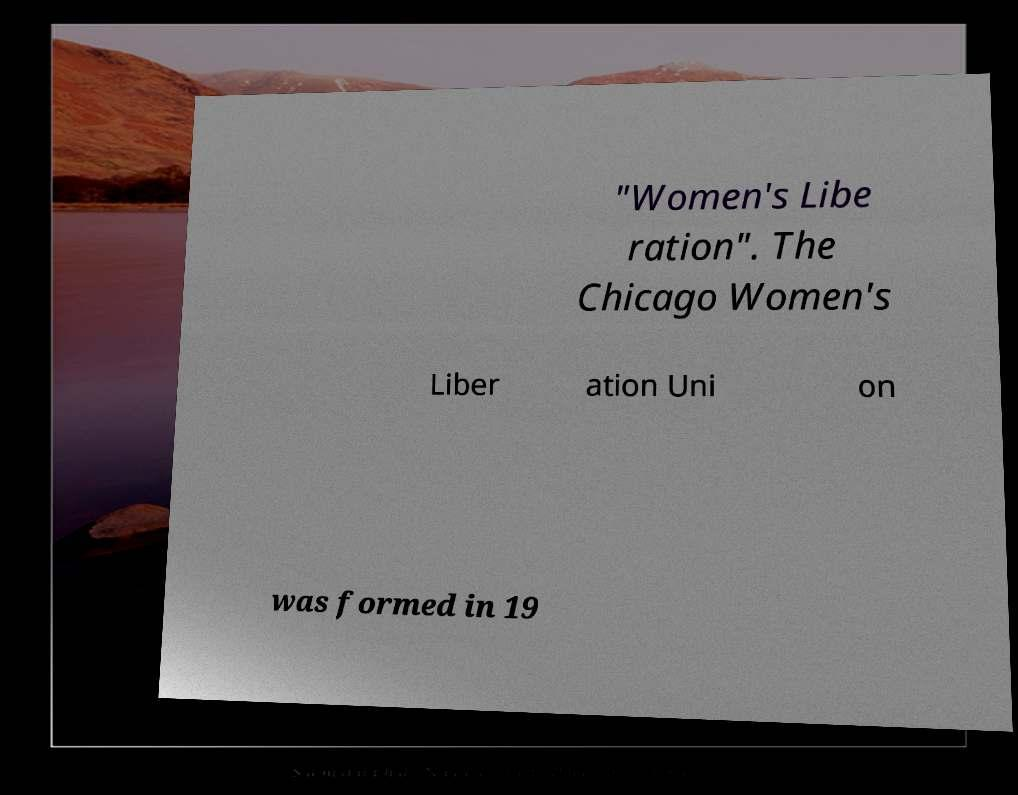What messages or text are displayed in this image? I need them in a readable, typed format. "Women's Libe ration". The Chicago Women's Liber ation Uni on was formed in 19 